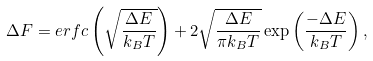<formula> <loc_0><loc_0><loc_500><loc_500>\Delta F = e r f c \left ( \sqrt { \frac { \Delta E } { k _ { B } T } } \right ) + 2 \sqrt { \frac { \Delta E } { \pi k _ { B } T } } \exp \left ( \frac { - \Delta E } { k _ { B } T } \right ) ,</formula> 